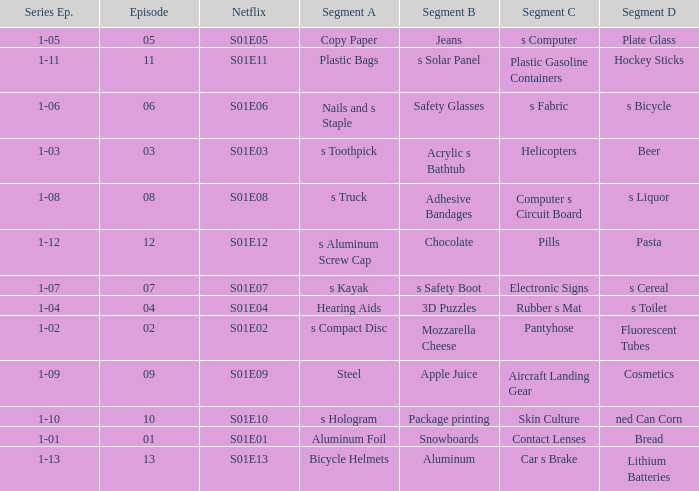What is the segment A name, having a Netflix of s01e12? S aluminum screw cap. 